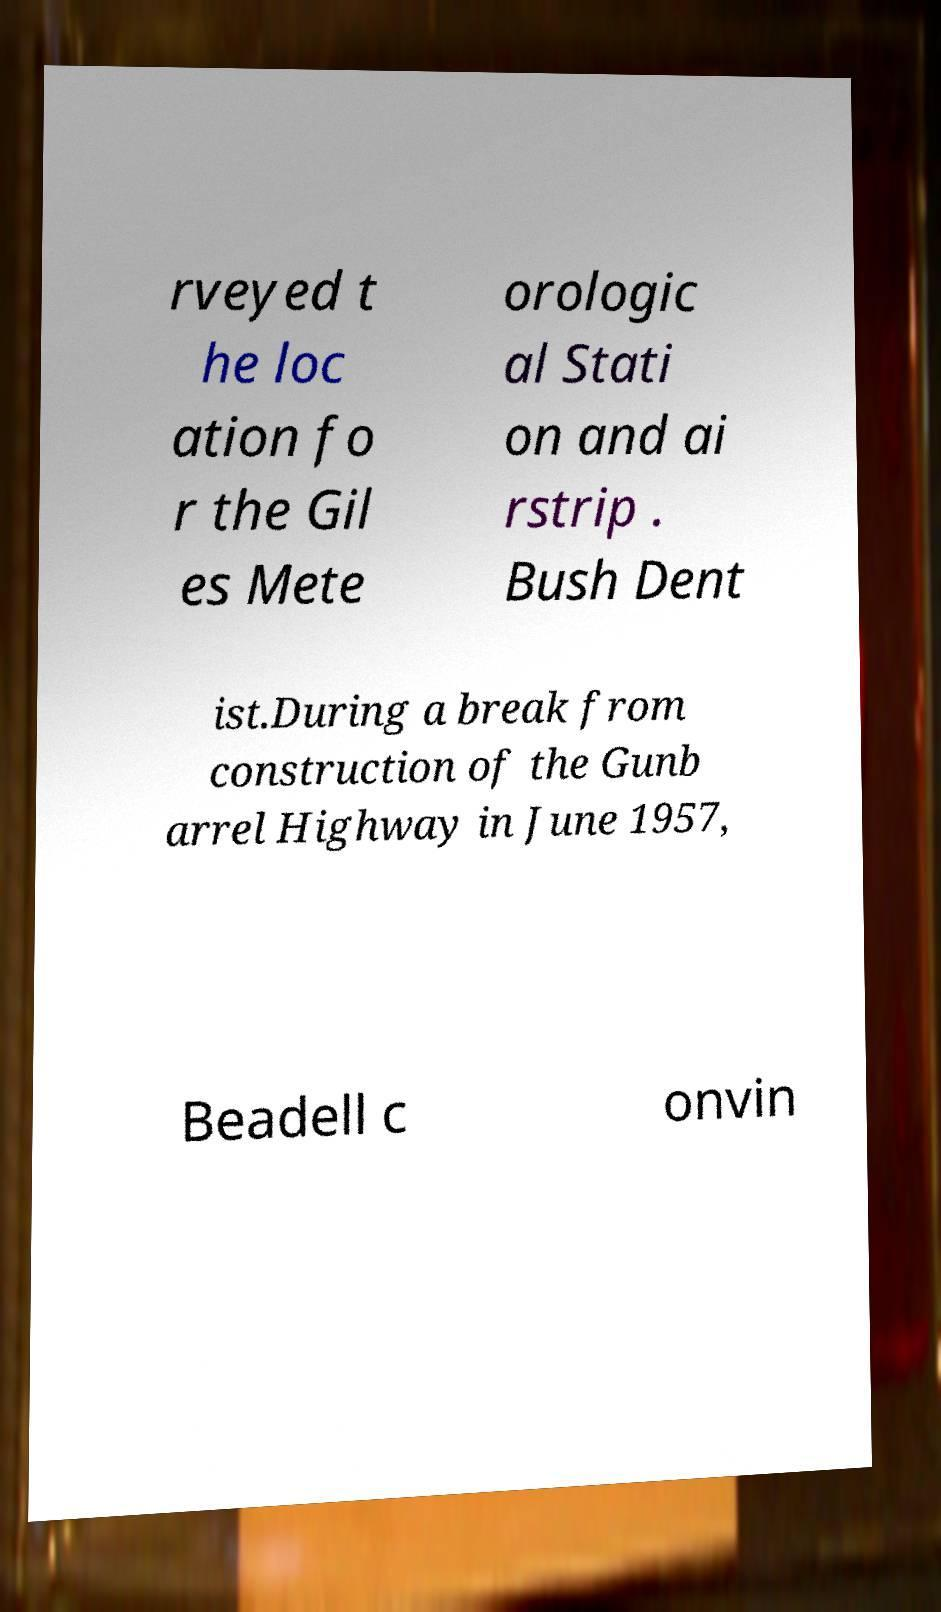Can you read and provide the text displayed in the image?This photo seems to have some interesting text. Can you extract and type it out for me? rveyed t he loc ation fo r the Gil es Mete orologic al Stati on and ai rstrip . Bush Dent ist.During a break from construction of the Gunb arrel Highway in June 1957, Beadell c onvin 